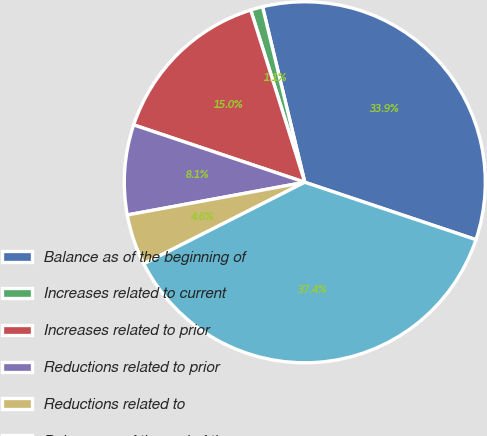Convert chart to OTSL. <chart><loc_0><loc_0><loc_500><loc_500><pie_chart><fcel>Balance as of the beginning of<fcel>Increases related to current<fcel>Increases related to prior<fcel>Reductions related to prior<fcel>Reductions related to<fcel>Balance as of the end of the<nl><fcel>33.91%<fcel>1.08%<fcel>15.01%<fcel>8.05%<fcel>4.56%<fcel>37.39%<nl></chart> 